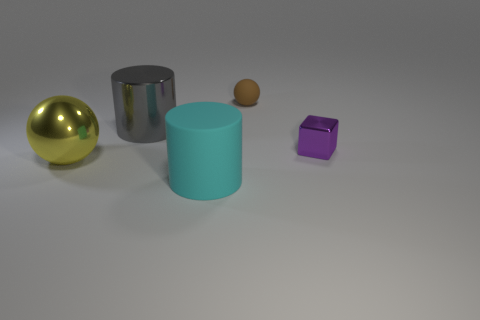Add 2 big cyan matte blocks. How many objects exist? 7 Subtract all cylinders. How many objects are left? 3 Subtract 0 red cubes. How many objects are left? 5 Subtract all purple things. Subtract all gray metal cylinders. How many objects are left? 3 Add 4 large cyan things. How many large cyan things are left? 5 Add 2 large yellow shiny things. How many large yellow shiny things exist? 3 